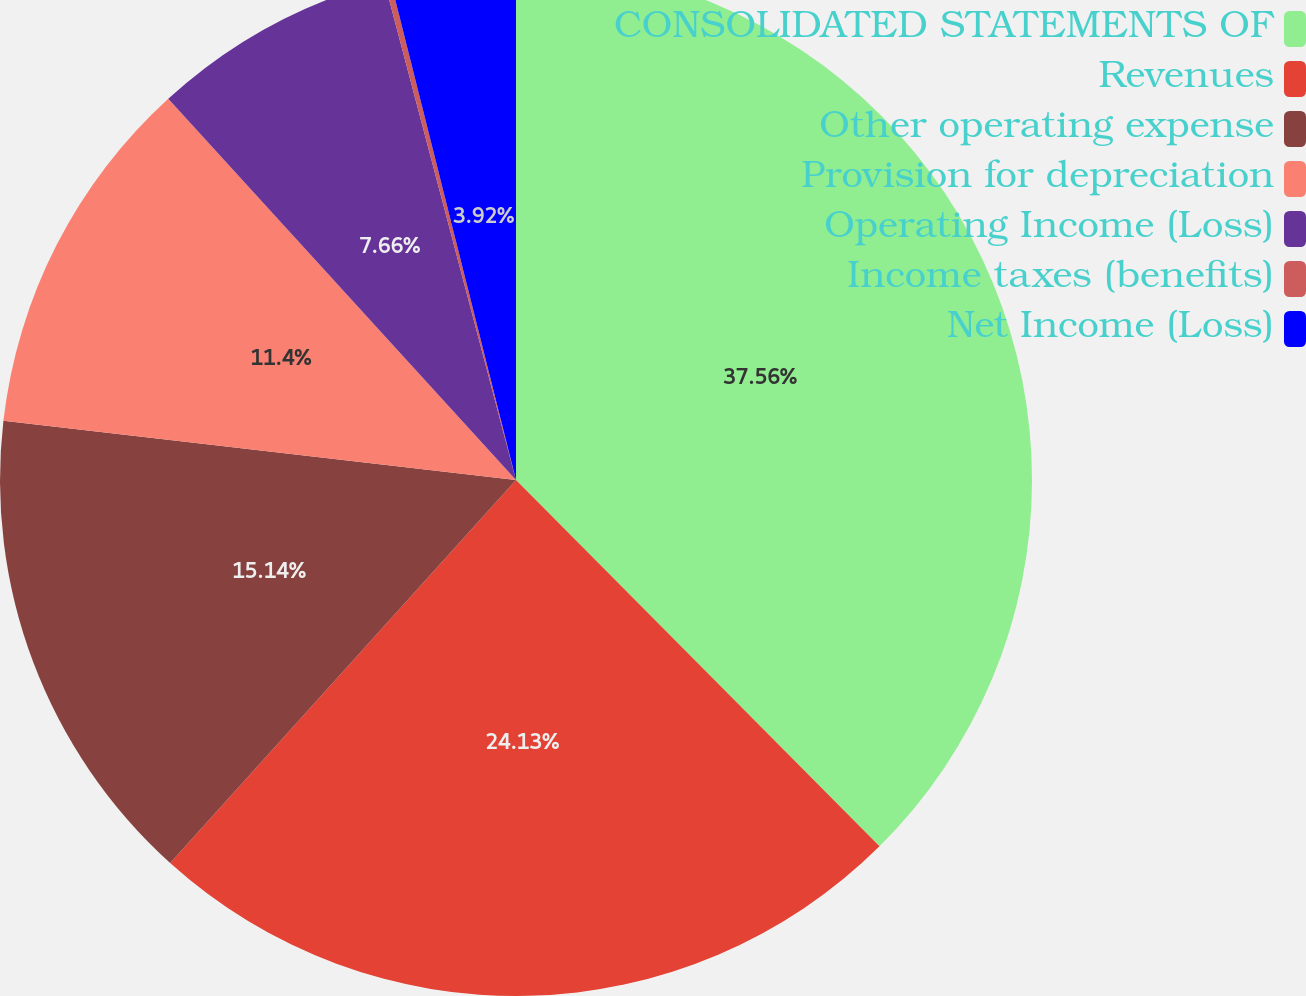<chart> <loc_0><loc_0><loc_500><loc_500><pie_chart><fcel>CONSOLIDATED STATEMENTS OF<fcel>Revenues<fcel>Other operating expense<fcel>Provision for depreciation<fcel>Operating Income (Loss)<fcel>Income taxes (benefits)<fcel>Net Income (Loss)<nl><fcel>37.56%<fcel>24.13%<fcel>15.14%<fcel>11.4%<fcel>7.66%<fcel>0.19%<fcel>3.92%<nl></chart> 